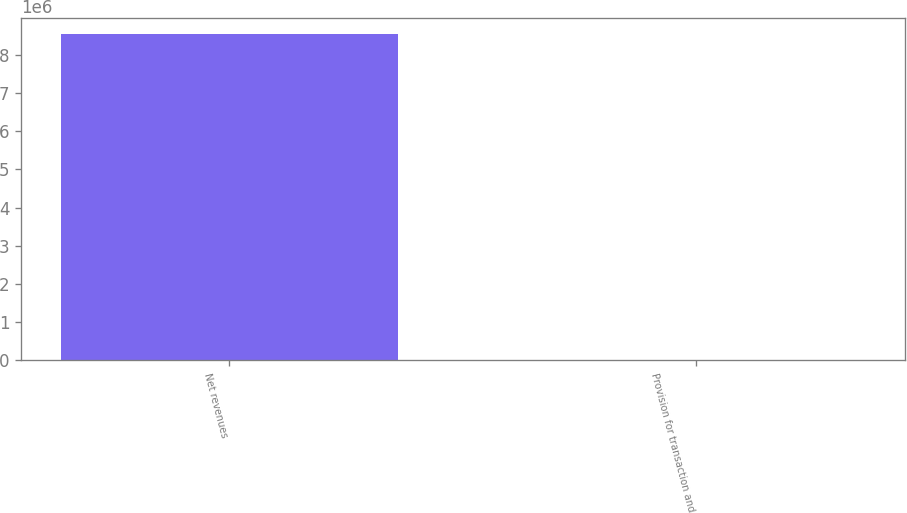<chart> <loc_0><loc_0><loc_500><loc_500><bar_chart><fcel>Net revenues<fcel>Provision for transaction and<nl><fcel>8.54126e+06<fcel>4.1<nl></chart> 